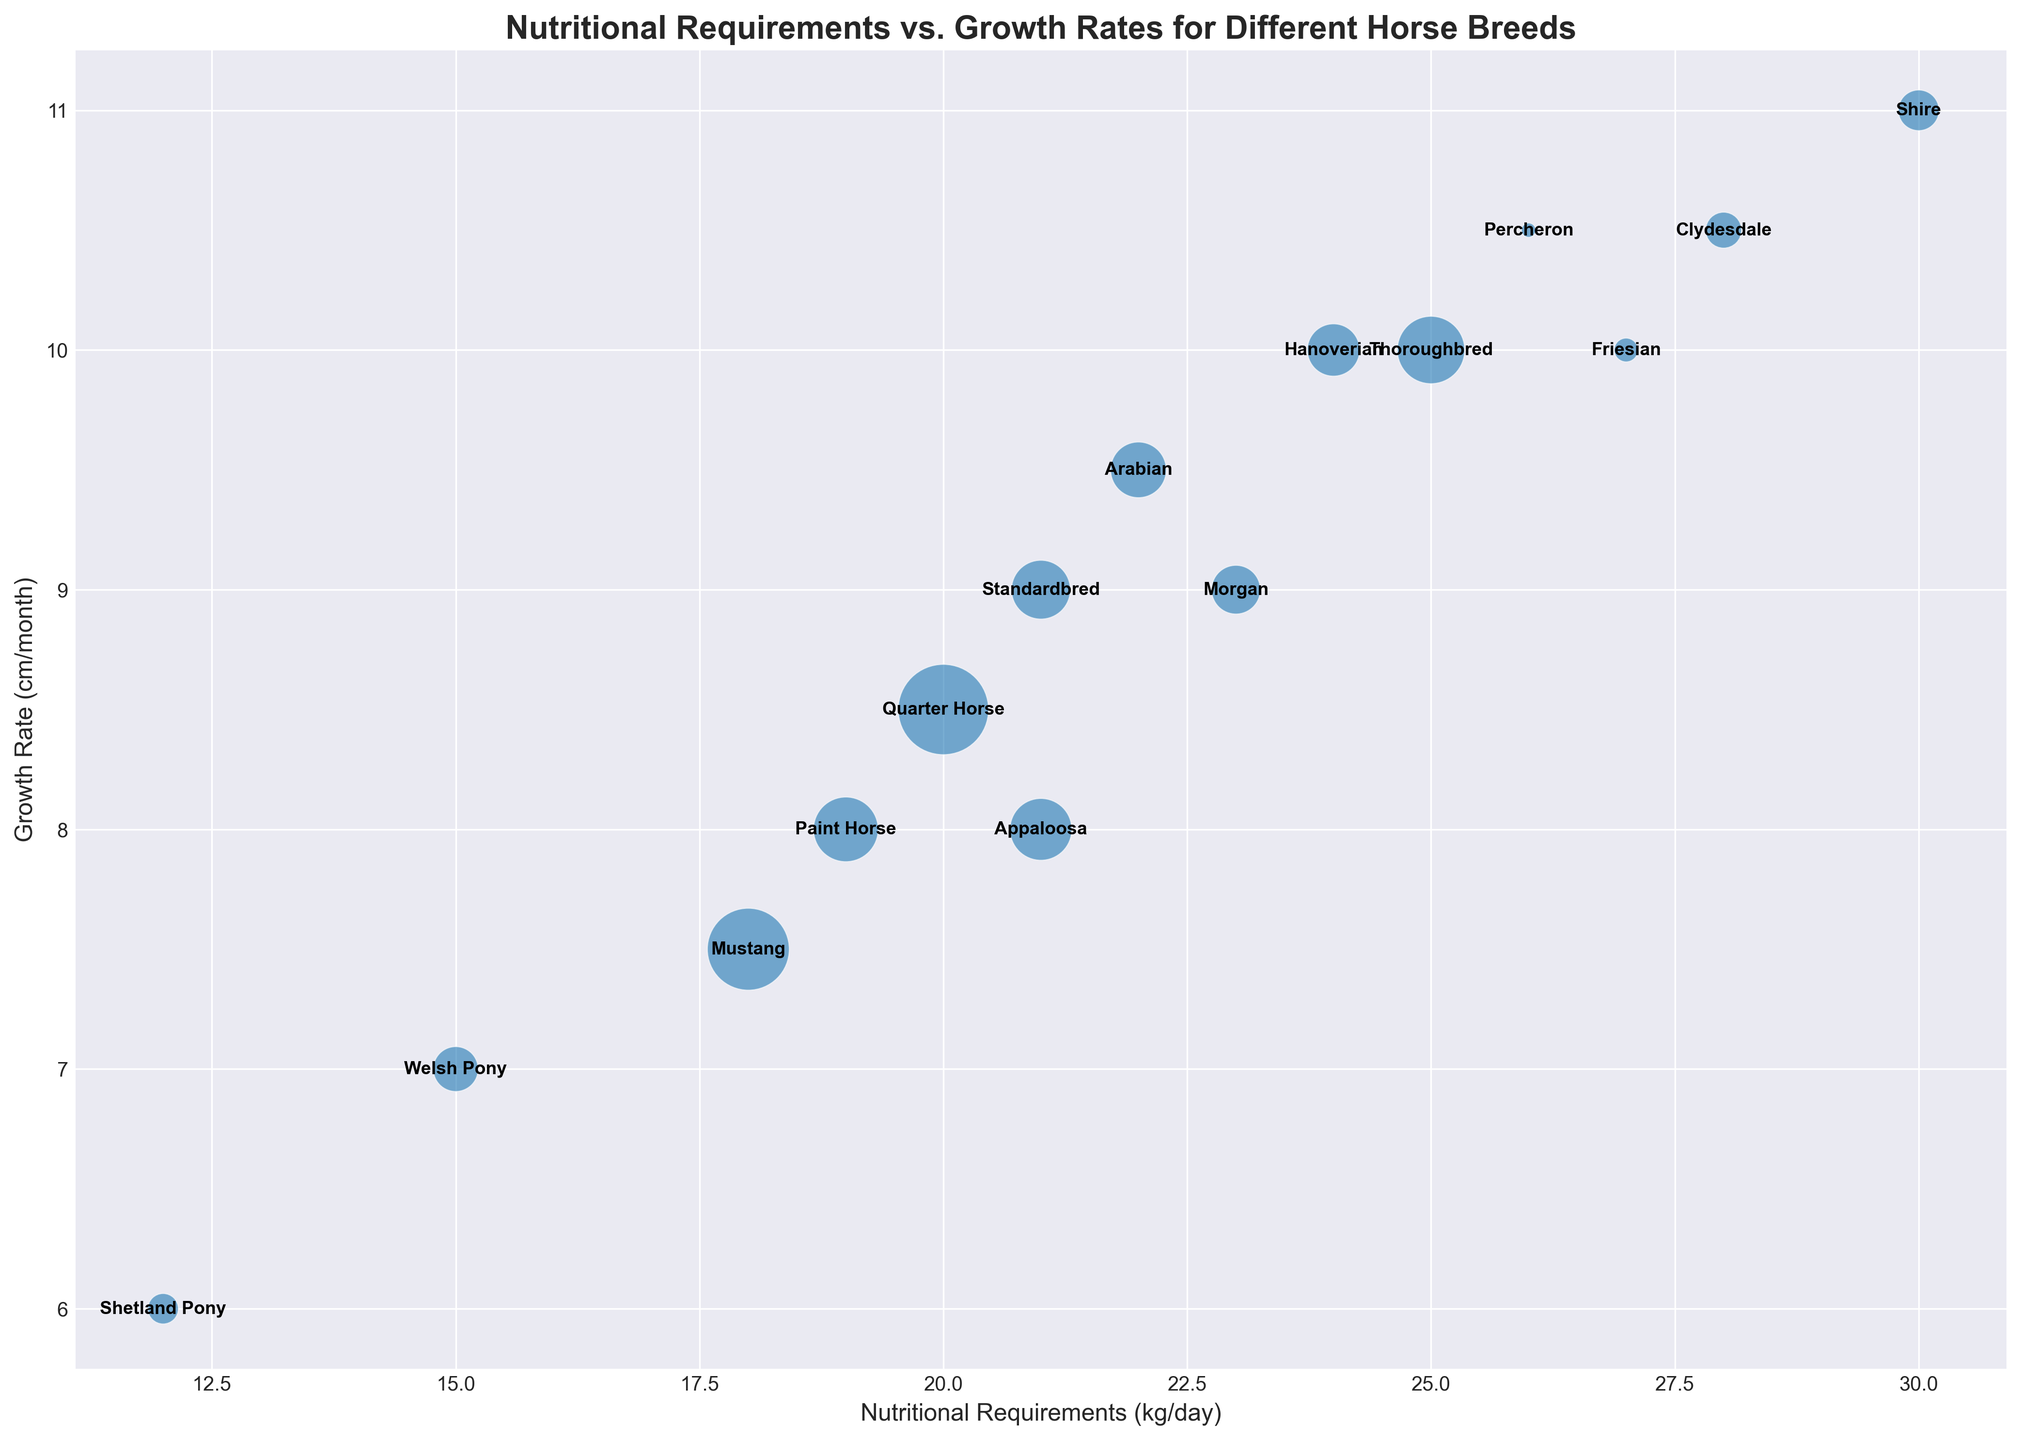Which breed has the highest nutritional requirement? The breed with the highest nutritional requirement will be the breed located farthest to the right on the x-axis, since the x-axis represents nutritional requirements in kg/day.
Answer: Shire Which breed has the lowest growth rate? The breed with the lowest growth rate will be the breed located lowest on the y-axis, since the y-axis represents growth rates in cm/month.
Answer: Shetland Pony Which breed has the largest population? The breed with the largest population will be represented by the largest bubble size on the graph.
Answer: Quarter Horse Which two breeds have the same growth rate but differ in nutritional requirements? By examining breeds that align horizontally on the y-axis (same growth rate), we can determine which pairs differ in x-axis values (nutritional requirements).
Answer: Thoroughbred and Friesian How many breeds have a growth rate greater than 10 cm/month? Count the number of breeds whose bubbles are located above the 10 cm/month mark on the y-axis.
Answer: 5 Which breed has a lower nutritional requirement but a higher growth rate compared to Hanoverian? Locate Hanoverian on the graph and identify any bubble that is positioned above it (higher growth rate) and to the left (lower nutritional requirement).
Answer: Friesian What is the average growth rate of Shire and Clydesdale breeds? Add the growth rates of Shire and Clydesdale (11 + 10.5) and divide by 2 to find the average.
Answer: 10.75 cm/month Which breed shows an approximately equal bubble size and nutritional requirement as Paint Horse but differs in growth rate? Find a breed with similar bubble size (population) and nutritional requirement close to Paint Horse (Nutritional Requirements: 19 kg/day), but different vertical position (growth rate).
Answer: Standardbred How does the nutritional requirement of Morgan compare to Arabian? Morgan's nutritional requirement is represented by its horizontal position. Compare this with Arabian's horizontal position.
Answer: Morgan requires more, 23 kg/day vs. Arabian's 22 kg/day Which breed is identified by the smallest bubble and what is its growth rate? Locate the smallest bubble on the graph and identify its corresponding growth rate from its vertical position.
Answer: Percheron, 10.5 cm/month 